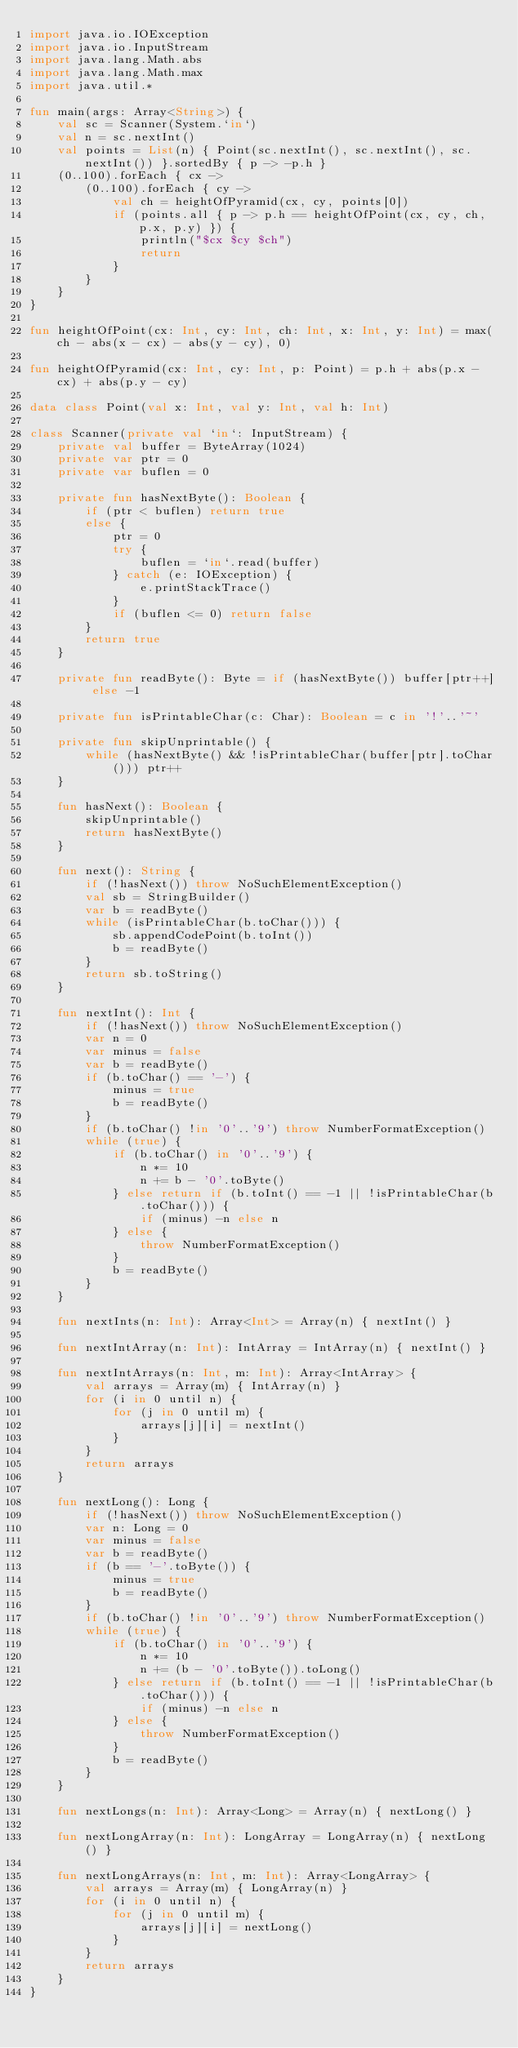<code> <loc_0><loc_0><loc_500><loc_500><_Kotlin_>import java.io.IOException
import java.io.InputStream
import java.lang.Math.abs
import java.lang.Math.max
import java.util.*

fun main(args: Array<String>) {
    val sc = Scanner(System.`in`)
    val n = sc.nextInt()
    val points = List(n) { Point(sc.nextInt(), sc.nextInt(), sc.nextInt()) }.sortedBy { p -> -p.h }
    (0..100).forEach { cx ->
        (0..100).forEach { cy ->
            val ch = heightOfPyramid(cx, cy, points[0])
            if (points.all { p -> p.h == heightOfPoint(cx, cy, ch, p.x, p.y) }) {
                println("$cx $cy $ch")
                return
            }
        }
    }
}

fun heightOfPoint(cx: Int, cy: Int, ch: Int, x: Int, y: Int) = max(ch - abs(x - cx) - abs(y - cy), 0)

fun heightOfPyramid(cx: Int, cy: Int, p: Point) = p.h + abs(p.x - cx) + abs(p.y - cy)

data class Point(val x: Int, val y: Int, val h: Int)

class Scanner(private val `in`: InputStream) {
    private val buffer = ByteArray(1024)
    private var ptr = 0
    private var buflen = 0

    private fun hasNextByte(): Boolean {
        if (ptr < buflen) return true
        else {
            ptr = 0
            try {
                buflen = `in`.read(buffer)
            } catch (e: IOException) {
                e.printStackTrace()
            }
            if (buflen <= 0) return false
        }
        return true
    }

    private fun readByte(): Byte = if (hasNextByte()) buffer[ptr++] else -1

    private fun isPrintableChar(c: Char): Boolean = c in '!'..'~'

    private fun skipUnprintable() {
        while (hasNextByte() && !isPrintableChar(buffer[ptr].toChar())) ptr++
    }

    fun hasNext(): Boolean {
        skipUnprintable()
        return hasNextByte()
    }

    fun next(): String {
        if (!hasNext()) throw NoSuchElementException()
        val sb = StringBuilder()
        var b = readByte()
        while (isPrintableChar(b.toChar())) {
            sb.appendCodePoint(b.toInt())
            b = readByte()
        }
        return sb.toString()
    }

    fun nextInt(): Int {
        if (!hasNext()) throw NoSuchElementException()
        var n = 0
        var minus = false
        var b = readByte()
        if (b.toChar() == '-') {
            minus = true
            b = readByte()
        }
        if (b.toChar() !in '0'..'9') throw NumberFormatException()
        while (true) {
            if (b.toChar() in '0'..'9') {
                n *= 10
                n += b - '0'.toByte()
            } else return if (b.toInt() == -1 || !isPrintableChar(b.toChar())) {
                if (minus) -n else n
            } else {
                throw NumberFormatException()
            }
            b = readByte()
        }
    }

    fun nextInts(n: Int): Array<Int> = Array(n) { nextInt() }

    fun nextIntArray(n: Int): IntArray = IntArray(n) { nextInt() }

    fun nextIntArrays(n: Int, m: Int): Array<IntArray> {
        val arrays = Array(m) { IntArray(n) }
        for (i in 0 until n) {
            for (j in 0 until m) {
                arrays[j][i] = nextInt()
            }
        }
        return arrays
    }

    fun nextLong(): Long {
        if (!hasNext()) throw NoSuchElementException()
        var n: Long = 0
        var minus = false
        var b = readByte()
        if (b == '-'.toByte()) {
            minus = true
            b = readByte()
        }
        if (b.toChar() !in '0'..'9') throw NumberFormatException()
        while (true) {
            if (b.toChar() in '0'..'9') {
                n *= 10
                n += (b - '0'.toByte()).toLong()
            } else return if (b.toInt() == -1 || !isPrintableChar(b.toChar())) {
                if (minus) -n else n
            } else {
                throw NumberFormatException()
            }
            b = readByte()
        }
    }

    fun nextLongs(n: Int): Array<Long> = Array(n) { nextLong() }

    fun nextLongArray(n: Int): LongArray = LongArray(n) { nextLong() }

    fun nextLongArrays(n: Int, m: Int): Array<LongArray> {
        val arrays = Array(m) { LongArray(n) }
        for (i in 0 until n) {
            for (j in 0 until m) {
                arrays[j][i] = nextLong()
            }
        }
        return arrays
    }
}
</code> 